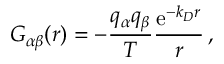<formula> <loc_0><loc_0><loc_500><loc_500>G _ { \alpha \beta } ( r ) = - \frac { q _ { \alpha } q _ { \beta } } { T } \frac { e ^ { - k _ { D } r } } { r } \, ,</formula> 